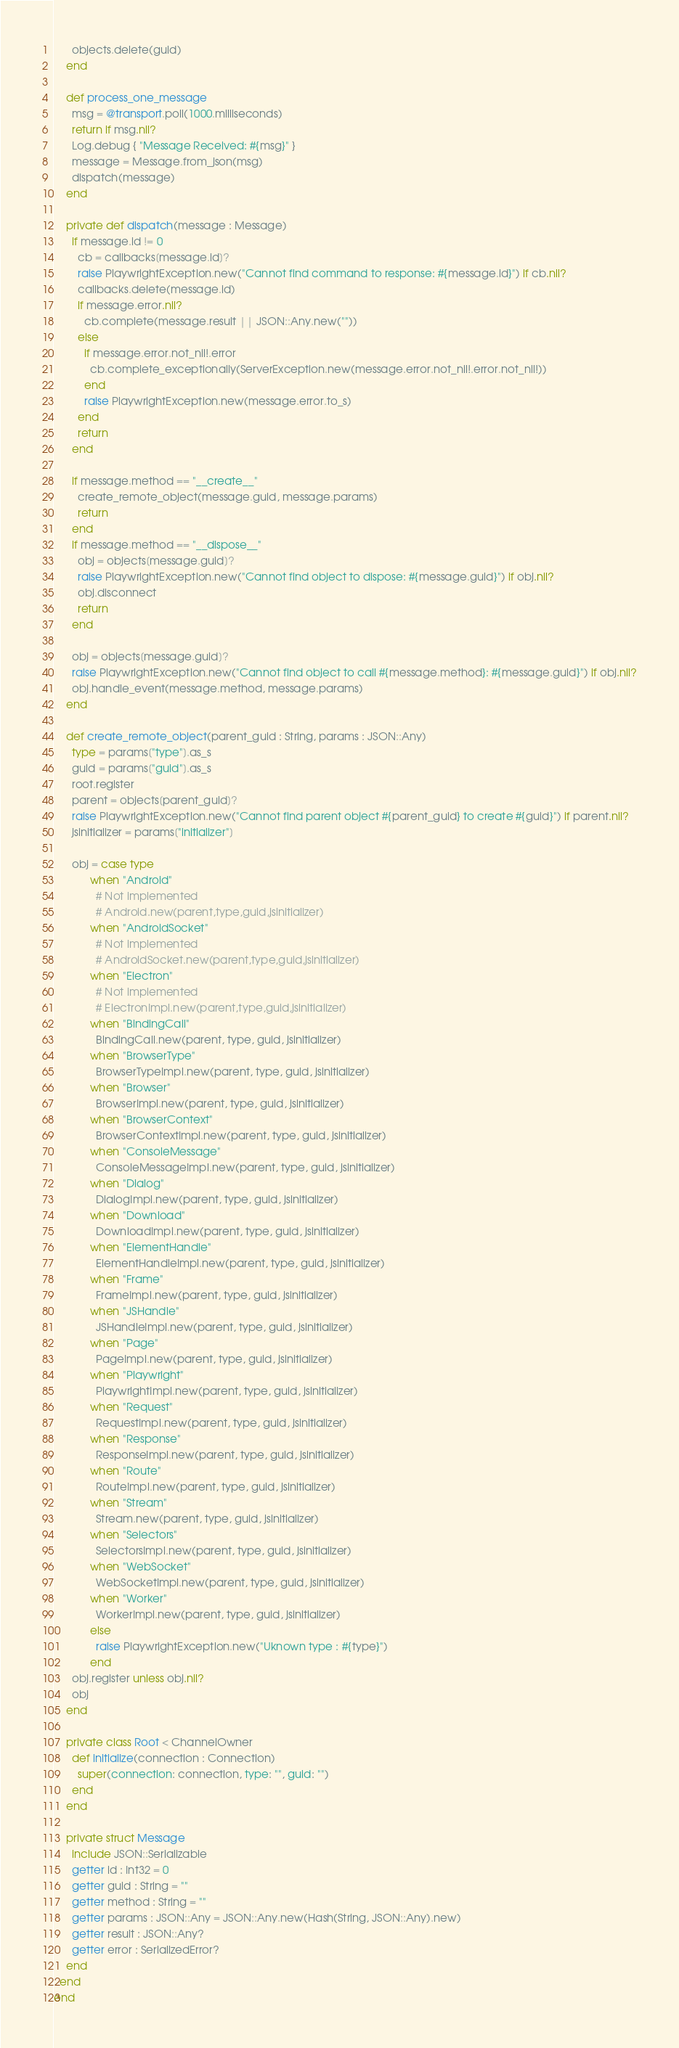Convert code to text. <code><loc_0><loc_0><loc_500><loc_500><_Crystal_>      objects.delete(guid)
    end

    def process_one_message
      msg = @transport.poll(1000.milliseconds)
      return if msg.nil?
      Log.debug { "Message Received: #{msg}" }
      message = Message.from_json(msg)
      dispatch(message)
    end

    private def dispatch(message : Message)
      if message.id != 0
        cb = callbacks[message.id]?
        raise PlaywrightException.new("Cannot find command to response: #{message.id}") if cb.nil?
        callbacks.delete(message.id)
        if message.error.nil?
          cb.complete(message.result || JSON::Any.new(""))
        else
          if message.error.not_nil!.error
            cb.complete_exceptionally(ServerException.new(message.error.not_nil!.error.not_nil!))
          end
          raise PlaywrightException.new(message.error.to_s)
        end
        return
      end

      if message.method == "__create__"
        create_remote_object(message.guid, message.params)
        return
      end
      if message.method == "__dispose__"
        obj = objects[message.guid]?
        raise PlaywrightException.new("Cannot find object to dispose: #{message.guid}") if obj.nil?
        obj.disconnect
        return
      end

      obj = objects[message.guid]?
      raise PlaywrightException.new("Cannot find object to call #{message.method}: #{message.guid}") if obj.nil?
      obj.handle_event(message.method, message.params)
    end

    def create_remote_object(parent_guid : String, params : JSON::Any)
      type = params["type"].as_s
      guid = params["guid"].as_s
      root.register
      parent = objects[parent_guid]?
      raise PlaywrightException.new("Cannot find parent object #{parent_guid} to create #{guid}") if parent.nil?
      jsinitializer = params["initializer"]

      obj = case type
            when "Android"
              # Not implemented
              # Android.new(parent,type,guid,jsinitializer)
            when "AndroidSocket"
              # Not implemented
              # AndroidSocket.new(parent,type,guid,jsinitializer)
            when "Electron"
              # Not implemented
              # ElectronImpl.new(parent,type,guid,jsinitializer)
            when "BindingCall"
              BindingCall.new(parent, type, guid, jsinitializer)
            when "BrowserType"
              BrowserTypeImpl.new(parent, type, guid, jsinitializer)
            when "Browser"
              BrowserImpl.new(parent, type, guid, jsinitializer)
            when "BrowserContext"
              BrowserContextImpl.new(parent, type, guid, jsinitializer)
            when "ConsoleMessage"
              ConsoleMessageImpl.new(parent, type, guid, jsinitializer)
            when "Dialog"
              DialogImpl.new(parent, type, guid, jsinitializer)
            when "Download"
              DownloadImpl.new(parent, type, guid, jsinitializer)
            when "ElementHandle"
              ElementHandleImpl.new(parent, type, guid, jsinitializer)
            when "Frame"
              FrameImpl.new(parent, type, guid, jsinitializer)
            when "JSHandle"
              JSHandleImpl.new(parent, type, guid, jsinitializer)
            when "Page"
              PageImpl.new(parent, type, guid, jsinitializer)
            when "Playwright"
              PlaywrightImpl.new(parent, type, guid, jsinitializer)
            when "Request"
              RequestImpl.new(parent, type, guid, jsinitializer)
            when "Response"
              ResponseImpl.new(parent, type, guid, jsinitializer)
            when "Route"
              RouteImpl.new(parent, type, guid, jsinitializer)
            when "Stream"
              Stream.new(parent, type, guid, jsinitializer)
            when "Selectors"
              SelectorsImpl.new(parent, type, guid, jsinitializer)
            when "WebSocket"
              WebSocketImpl.new(parent, type, guid, jsinitializer)
            when "Worker"
              WorkerImpl.new(parent, type, guid, jsinitializer)
            else
              raise PlaywrightException.new("Uknown type : #{type}")
            end
      obj.register unless obj.nil?
      obj
    end

    private class Root < ChannelOwner
      def initialize(connection : Connection)
        super(connection: connection, type: "", guid: "")
      end
    end

    private struct Message
      include JSON::Serializable
      getter id : Int32 = 0
      getter guid : String = ""
      getter method : String = ""
      getter params : JSON::Any = JSON::Any.new(Hash(String, JSON::Any).new)
      getter result : JSON::Any?
      getter error : SerializedError?
    end
  end
end
</code> 